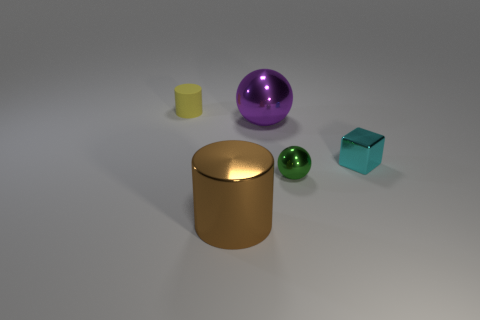Add 2 cyan cubes. How many objects exist? 7 Subtract all cubes. How many objects are left? 4 Subtract 0 red cubes. How many objects are left? 5 Subtract all cyan things. Subtract all blue matte cylinders. How many objects are left? 4 Add 2 big purple objects. How many big purple objects are left? 3 Add 3 tiny cyan metal objects. How many tiny cyan metal objects exist? 4 